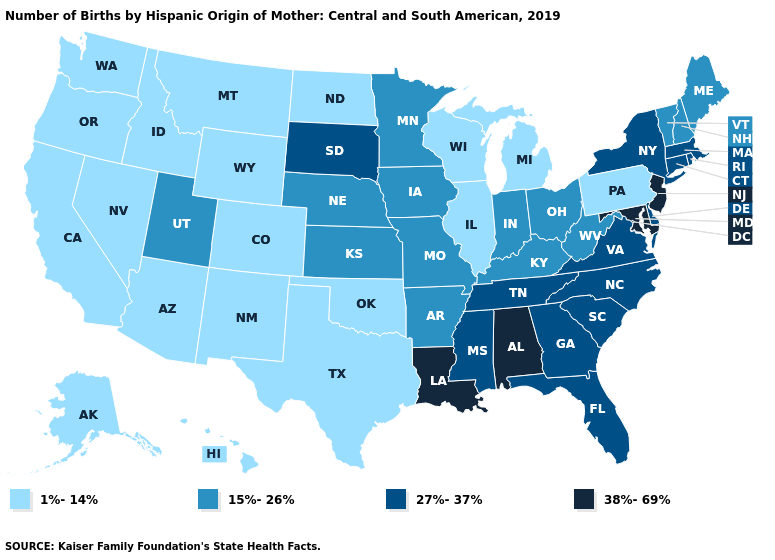Does Michigan have the lowest value in the MidWest?
Concise answer only. Yes. What is the value of Vermont?
Short answer required. 15%-26%. What is the value of North Carolina?
Give a very brief answer. 27%-37%. What is the lowest value in the MidWest?
Write a very short answer. 1%-14%. Does California have a lower value than Rhode Island?
Concise answer only. Yes. What is the highest value in the South ?
Concise answer only. 38%-69%. Name the states that have a value in the range 38%-69%?
Write a very short answer. Alabama, Louisiana, Maryland, New Jersey. Does the map have missing data?
Concise answer only. No. Does Maryland have the highest value in the USA?
Short answer required. Yes. Does Maryland have the same value as Alabama?
Concise answer only. Yes. Among the states that border North Dakota , does Montana have the lowest value?
Quick response, please. Yes. Name the states that have a value in the range 1%-14%?
Answer briefly. Alaska, Arizona, California, Colorado, Hawaii, Idaho, Illinois, Michigan, Montana, Nevada, New Mexico, North Dakota, Oklahoma, Oregon, Pennsylvania, Texas, Washington, Wisconsin, Wyoming. Does Virginia have a higher value than Georgia?
Quick response, please. No. Does the first symbol in the legend represent the smallest category?
Concise answer only. Yes. Name the states that have a value in the range 1%-14%?
Keep it brief. Alaska, Arizona, California, Colorado, Hawaii, Idaho, Illinois, Michigan, Montana, Nevada, New Mexico, North Dakota, Oklahoma, Oregon, Pennsylvania, Texas, Washington, Wisconsin, Wyoming. 